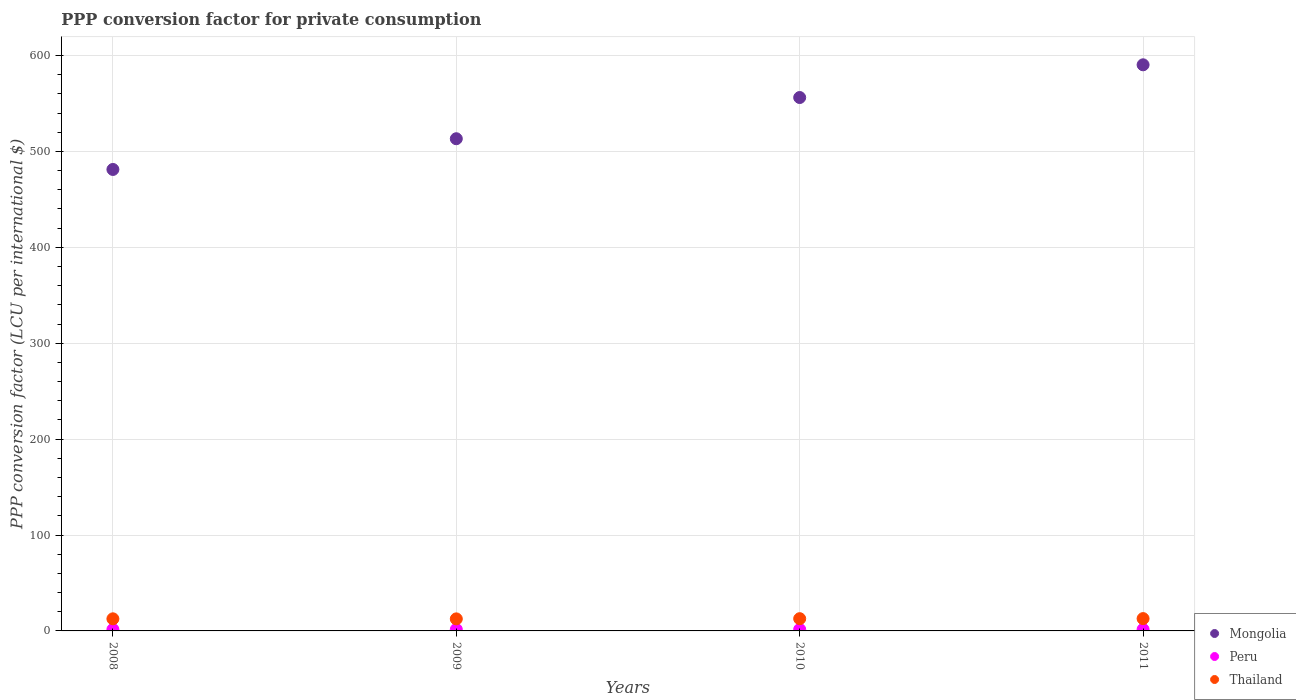How many different coloured dotlines are there?
Provide a short and direct response. 3. What is the PPP conversion factor for private consumption in Mongolia in 2011?
Make the answer very short. 590.33. Across all years, what is the maximum PPP conversion factor for private consumption in Peru?
Ensure brevity in your answer.  1.57. Across all years, what is the minimum PPP conversion factor for private consumption in Thailand?
Offer a very short reply. 12.56. In which year was the PPP conversion factor for private consumption in Thailand maximum?
Your answer should be compact. 2011. What is the total PPP conversion factor for private consumption in Thailand in the graph?
Offer a terse response. 50.79. What is the difference between the PPP conversion factor for private consumption in Peru in 2008 and that in 2009?
Provide a short and direct response. -0.05. What is the difference between the PPP conversion factor for private consumption in Thailand in 2009 and the PPP conversion factor for private consumption in Peru in 2008?
Offer a very short reply. 11.04. What is the average PPP conversion factor for private consumption in Mongolia per year?
Your answer should be compact. 535.25. In the year 2008, what is the difference between the PPP conversion factor for private consumption in Thailand and PPP conversion factor for private consumption in Peru?
Keep it short and to the point. 11.11. In how many years, is the PPP conversion factor for private consumption in Thailand greater than 180 LCU?
Make the answer very short. 0. What is the ratio of the PPP conversion factor for private consumption in Peru in 2008 to that in 2009?
Ensure brevity in your answer.  0.97. What is the difference between the highest and the second highest PPP conversion factor for private consumption in Thailand?
Offer a very short reply. 0.08. What is the difference between the highest and the lowest PPP conversion factor for private consumption in Thailand?
Your answer should be compact. 0.28. Is the sum of the PPP conversion factor for private consumption in Peru in 2008 and 2009 greater than the maximum PPP conversion factor for private consumption in Thailand across all years?
Offer a very short reply. No. Is it the case that in every year, the sum of the PPP conversion factor for private consumption in Mongolia and PPP conversion factor for private consumption in Thailand  is greater than the PPP conversion factor for private consumption in Peru?
Offer a terse response. Yes. Is the PPP conversion factor for private consumption in Thailand strictly greater than the PPP conversion factor for private consumption in Peru over the years?
Your answer should be very brief. Yes. How many dotlines are there?
Provide a succinct answer. 3. What is the difference between two consecutive major ticks on the Y-axis?
Offer a very short reply. 100. Are the values on the major ticks of Y-axis written in scientific E-notation?
Your response must be concise. No. Does the graph contain grids?
Make the answer very short. Yes. Where does the legend appear in the graph?
Your answer should be compact. Bottom right. How many legend labels are there?
Provide a succinct answer. 3. What is the title of the graph?
Ensure brevity in your answer.  PPP conversion factor for private consumption. Does "Albania" appear as one of the legend labels in the graph?
Ensure brevity in your answer.  No. What is the label or title of the Y-axis?
Your answer should be compact. PPP conversion factor (LCU per international $). What is the PPP conversion factor (LCU per international $) of Mongolia in 2008?
Offer a very short reply. 481.2. What is the PPP conversion factor (LCU per international $) of Peru in 2008?
Ensure brevity in your answer.  1.52. What is the PPP conversion factor (LCU per international $) in Thailand in 2008?
Ensure brevity in your answer.  12.62. What is the PPP conversion factor (LCU per international $) of Mongolia in 2009?
Your response must be concise. 513.24. What is the PPP conversion factor (LCU per international $) of Peru in 2009?
Give a very brief answer. 1.57. What is the PPP conversion factor (LCU per international $) in Thailand in 2009?
Give a very brief answer. 12.56. What is the PPP conversion factor (LCU per international $) in Mongolia in 2010?
Your response must be concise. 556.21. What is the PPP conversion factor (LCU per international $) of Peru in 2010?
Your answer should be compact. 1.57. What is the PPP conversion factor (LCU per international $) of Thailand in 2010?
Offer a terse response. 12.76. What is the PPP conversion factor (LCU per international $) of Mongolia in 2011?
Ensure brevity in your answer.  590.33. What is the PPP conversion factor (LCU per international $) of Peru in 2011?
Offer a terse response. 1.57. What is the PPP conversion factor (LCU per international $) in Thailand in 2011?
Give a very brief answer. 12.84. Across all years, what is the maximum PPP conversion factor (LCU per international $) in Mongolia?
Ensure brevity in your answer.  590.33. Across all years, what is the maximum PPP conversion factor (LCU per international $) in Peru?
Make the answer very short. 1.57. Across all years, what is the maximum PPP conversion factor (LCU per international $) of Thailand?
Provide a short and direct response. 12.84. Across all years, what is the minimum PPP conversion factor (LCU per international $) in Mongolia?
Your answer should be compact. 481.2. Across all years, what is the minimum PPP conversion factor (LCU per international $) of Peru?
Provide a short and direct response. 1.52. Across all years, what is the minimum PPP conversion factor (LCU per international $) in Thailand?
Your answer should be very brief. 12.56. What is the total PPP conversion factor (LCU per international $) of Mongolia in the graph?
Provide a short and direct response. 2140.99. What is the total PPP conversion factor (LCU per international $) in Peru in the graph?
Ensure brevity in your answer.  6.22. What is the total PPP conversion factor (LCU per international $) of Thailand in the graph?
Provide a succinct answer. 50.79. What is the difference between the PPP conversion factor (LCU per international $) of Mongolia in 2008 and that in 2009?
Give a very brief answer. -32.04. What is the difference between the PPP conversion factor (LCU per international $) in Peru in 2008 and that in 2009?
Give a very brief answer. -0.05. What is the difference between the PPP conversion factor (LCU per international $) in Thailand in 2008 and that in 2009?
Your answer should be very brief. 0.06. What is the difference between the PPP conversion factor (LCU per international $) in Mongolia in 2008 and that in 2010?
Your answer should be very brief. -75.01. What is the difference between the PPP conversion factor (LCU per international $) of Peru in 2008 and that in 2010?
Your response must be concise. -0.05. What is the difference between the PPP conversion factor (LCU per international $) in Thailand in 2008 and that in 2010?
Offer a very short reply. -0.14. What is the difference between the PPP conversion factor (LCU per international $) of Mongolia in 2008 and that in 2011?
Make the answer very short. -109.13. What is the difference between the PPP conversion factor (LCU per international $) of Peru in 2008 and that in 2011?
Keep it short and to the point. -0.05. What is the difference between the PPP conversion factor (LCU per international $) in Thailand in 2008 and that in 2011?
Offer a terse response. -0.22. What is the difference between the PPP conversion factor (LCU per international $) of Mongolia in 2009 and that in 2010?
Keep it short and to the point. -42.97. What is the difference between the PPP conversion factor (LCU per international $) in Peru in 2009 and that in 2010?
Offer a very short reply. 0. What is the difference between the PPP conversion factor (LCU per international $) in Thailand in 2009 and that in 2010?
Your answer should be compact. -0.2. What is the difference between the PPP conversion factor (LCU per international $) in Mongolia in 2009 and that in 2011?
Keep it short and to the point. -77.09. What is the difference between the PPP conversion factor (LCU per international $) in Peru in 2009 and that in 2011?
Your answer should be very brief. -0. What is the difference between the PPP conversion factor (LCU per international $) of Thailand in 2009 and that in 2011?
Your answer should be very brief. -0.28. What is the difference between the PPP conversion factor (LCU per international $) of Mongolia in 2010 and that in 2011?
Offer a very short reply. -34.12. What is the difference between the PPP conversion factor (LCU per international $) of Peru in 2010 and that in 2011?
Provide a succinct answer. -0. What is the difference between the PPP conversion factor (LCU per international $) of Thailand in 2010 and that in 2011?
Provide a short and direct response. -0.08. What is the difference between the PPP conversion factor (LCU per international $) in Mongolia in 2008 and the PPP conversion factor (LCU per international $) in Peru in 2009?
Provide a succinct answer. 479.64. What is the difference between the PPP conversion factor (LCU per international $) of Mongolia in 2008 and the PPP conversion factor (LCU per international $) of Thailand in 2009?
Your answer should be compact. 468.64. What is the difference between the PPP conversion factor (LCU per international $) in Peru in 2008 and the PPP conversion factor (LCU per international $) in Thailand in 2009?
Give a very brief answer. -11.04. What is the difference between the PPP conversion factor (LCU per international $) in Mongolia in 2008 and the PPP conversion factor (LCU per international $) in Peru in 2010?
Your answer should be compact. 479.64. What is the difference between the PPP conversion factor (LCU per international $) of Mongolia in 2008 and the PPP conversion factor (LCU per international $) of Thailand in 2010?
Ensure brevity in your answer.  468.44. What is the difference between the PPP conversion factor (LCU per international $) of Peru in 2008 and the PPP conversion factor (LCU per international $) of Thailand in 2010?
Offer a terse response. -11.25. What is the difference between the PPP conversion factor (LCU per international $) in Mongolia in 2008 and the PPP conversion factor (LCU per international $) in Peru in 2011?
Ensure brevity in your answer.  479.63. What is the difference between the PPP conversion factor (LCU per international $) of Mongolia in 2008 and the PPP conversion factor (LCU per international $) of Thailand in 2011?
Make the answer very short. 468.36. What is the difference between the PPP conversion factor (LCU per international $) in Peru in 2008 and the PPP conversion factor (LCU per international $) in Thailand in 2011?
Offer a terse response. -11.33. What is the difference between the PPP conversion factor (LCU per international $) of Mongolia in 2009 and the PPP conversion factor (LCU per international $) of Peru in 2010?
Keep it short and to the point. 511.68. What is the difference between the PPP conversion factor (LCU per international $) of Mongolia in 2009 and the PPP conversion factor (LCU per international $) of Thailand in 2010?
Your answer should be compact. 500.48. What is the difference between the PPP conversion factor (LCU per international $) of Peru in 2009 and the PPP conversion factor (LCU per international $) of Thailand in 2010?
Offer a terse response. -11.2. What is the difference between the PPP conversion factor (LCU per international $) in Mongolia in 2009 and the PPP conversion factor (LCU per international $) in Peru in 2011?
Provide a succinct answer. 511.68. What is the difference between the PPP conversion factor (LCU per international $) of Mongolia in 2009 and the PPP conversion factor (LCU per international $) of Thailand in 2011?
Provide a short and direct response. 500.4. What is the difference between the PPP conversion factor (LCU per international $) of Peru in 2009 and the PPP conversion factor (LCU per international $) of Thailand in 2011?
Offer a terse response. -11.28. What is the difference between the PPP conversion factor (LCU per international $) in Mongolia in 2010 and the PPP conversion factor (LCU per international $) in Peru in 2011?
Give a very brief answer. 554.65. What is the difference between the PPP conversion factor (LCU per international $) in Mongolia in 2010 and the PPP conversion factor (LCU per international $) in Thailand in 2011?
Give a very brief answer. 543.37. What is the difference between the PPP conversion factor (LCU per international $) of Peru in 2010 and the PPP conversion factor (LCU per international $) of Thailand in 2011?
Provide a succinct answer. -11.28. What is the average PPP conversion factor (LCU per international $) of Mongolia per year?
Your answer should be very brief. 535.25. What is the average PPP conversion factor (LCU per international $) of Peru per year?
Keep it short and to the point. 1.55. What is the average PPP conversion factor (LCU per international $) in Thailand per year?
Make the answer very short. 12.7. In the year 2008, what is the difference between the PPP conversion factor (LCU per international $) in Mongolia and PPP conversion factor (LCU per international $) in Peru?
Your answer should be compact. 479.69. In the year 2008, what is the difference between the PPP conversion factor (LCU per international $) in Mongolia and PPP conversion factor (LCU per international $) in Thailand?
Provide a succinct answer. 468.58. In the year 2008, what is the difference between the PPP conversion factor (LCU per international $) in Peru and PPP conversion factor (LCU per international $) in Thailand?
Provide a succinct answer. -11.11. In the year 2009, what is the difference between the PPP conversion factor (LCU per international $) in Mongolia and PPP conversion factor (LCU per international $) in Peru?
Make the answer very short. 511.68. In the year 2009, what is the difference between the PPP conversion factor (LCU per international $) in Mongolia and PPP conversion factor (LCU per international $) in Thailand?
Your answer should be compact. 500.68. In the year 2009, what is the difference between the PPP conversion factor (LCU per international $) in Peru and PPP conversion factor (LCU per international $) in Thailand?
Ensure brevity in your answer.  -10.99. In the year 2010, what is the difference between the PPP conversion factor (LCU per international $) of Mongolia and PPP conversion factor (LCU per international $) of Peru?
Provide a succinct answer. 554.65. In the year 2010, what is the difference between the PPP conversion factor (LCU per international $) in Mongolia and PPP conversion factor (LCU per international $) in Thailand?
Make the answer very short. 543.45. In the year 2010, what is the difference between the PPP conversion factor (LCU per international $) of Peru and PPP conversion factor (LCU per international $) of Thailand?
Make the answer very short. -11.2. In the year 2011, what is the difference between the PPP conversion factor (LCU per international $) in Mongolia and PPP conversion factor (LCU per international $) in Peru?
Your response must be concise. 588.76. In the year 2011, what is the difference between the PPP conversion factor (LCU per international $) of Mongolia and PPP conversion factor (LCU per international $) of Thailand?
Offer a terse response. 577.49. In the year 2011, what is the difference between the PPP conversion factor (LCU per international $) in Peru and PPP conversion factor (LCU per international $) in Thailand?
Make the answer very short. -11.28. What is the ratio of the PPP conversion factor (LCU per international $) in Mongolia in 2008 to that in 2009?
Give a very brief answer. 0.94. What is the ratio of the PPP conversion factor (LCU per international $) in Peru in 2008 to that in 2009?
Keep it short and to the point. 0.97. What is the ratio of the PPP conversion factor (LCU per international $) of Mongolia in 2008 to that in 2010?
Offer a very short reply. 0.87. What is the ratio of the PPP conversion factor (LCU per international $) in Peru in 2008 to that in 2010?
Your answer should be compact. 0.97. What is the ratio of the PPP conversion factor (LCU per international $) in Mongolia in 2008 to that in 2011?
Make the answer very short. 0.82. What is the ratio of the PPP conversion factor (LCU per international $) in Peru in 2008 to that in 2011?
Your response must be concise. 0.97. What is the ratio of the PPP conversion factor (LCU per international $) of Thailand in 2008 to that in 2011?
Make the answer very short. 0.98. What is the ratio of the PPP conversion factor (LCU per international $) in Mongolia in 2009 to that in 2010?
Keep it short and to the point. 0.92. What is the ratio of the PPP conversion factor (LCU per international $) in Peru in 2009 to that in 2010?
Your answer should be compact. 1. What is the ratio of the PPP conversion factor (LCU per international $) of Thailand in 2009 to that in 2010?
Keep it short and to the point. 0.98. What is the ratio of the PPP conversion factor (LCU per international $) in Mongolia in 2009 to that in 2011?
Offer a very short reply. 0.87. What is the ratio of the PPP conversion factor (LCU per international $) of Mongolia in 2010 to that in 2011?
Ensure brevity in your answer.  0.94. What is the ratio of the PPP conversion factor (LCU per international $) of Peru in 2010 to that in 2011?
Offer a terse response. 1. What is the ratio of the PPP conversion factor (LCU per international $) in Thailand in 2010 to that in 2011?
Ensure brevity in your answer.  0.99. What is the difference between the highest and the second highest PPP conversion factor (LCU per international $) of Mongolia?
Give a very brief answer. 34.12. What is the difference between the highest and the second highest PPP conversion factor (LCU per international $) of Peru?
Your answer should be compact. 0. What is the difference between the highest and the second highest PPP conversion factor (LCU per international $) of Thailand?
Keep it short and to the point. 0.08. What is the difference between the highest and the lowest PPP conversion factor (LCU per international $) in Mongolia?
Provide a short and direct response. 109.13. What is the difference between the highest and the lowest PPP conversion factor (LCU per international $) of Peru?
Provide a succinct answer. 0.05. What is the difference between the highest and the lowest PPP conversion factor (LCU per international $) in Thailand?
Provide a succinct answer. 0.28. 